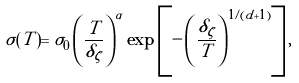Convert formula to latex. <formula><loc_0><loc_0><loc_500><loc_500>\sigma ( T ) = \sigma _ { 0 } \left ( \frac { T } { \delta _ { \zeta } } \right ) ^ { \alpha } \exp \left [ - \left ( \frac { \delta _ { \zeta } } { T } \right ) ^ { 1 / ( d + 1 ) } \right ] ,</formula> 